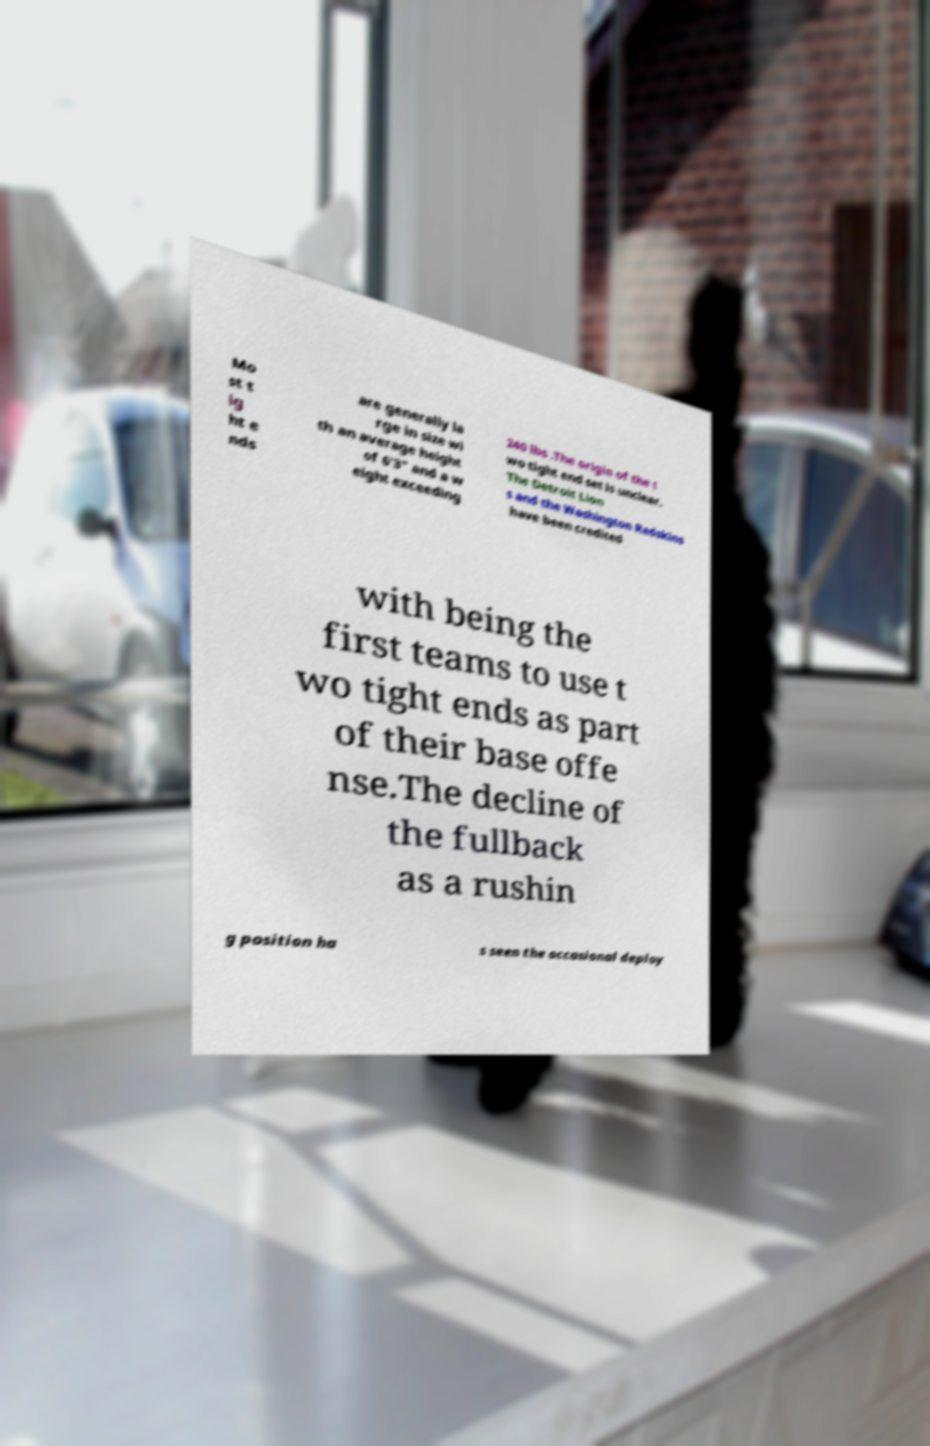What messages or text are displayed in this image? I need them in a readable, typed format. Mo st t ig ht e nds are generally la rge in size wi th an average height of 6'3" and a w eight exceeding 240 lbs .The origin of the t wo tight end set is unclear. The Detroit Lion s and the Washington Redskins have been credited with being the first teams to use t wo tight ends as part of their base offe nse.The decline of the fullback as a rushin g position ha s seen the occasional deploy 